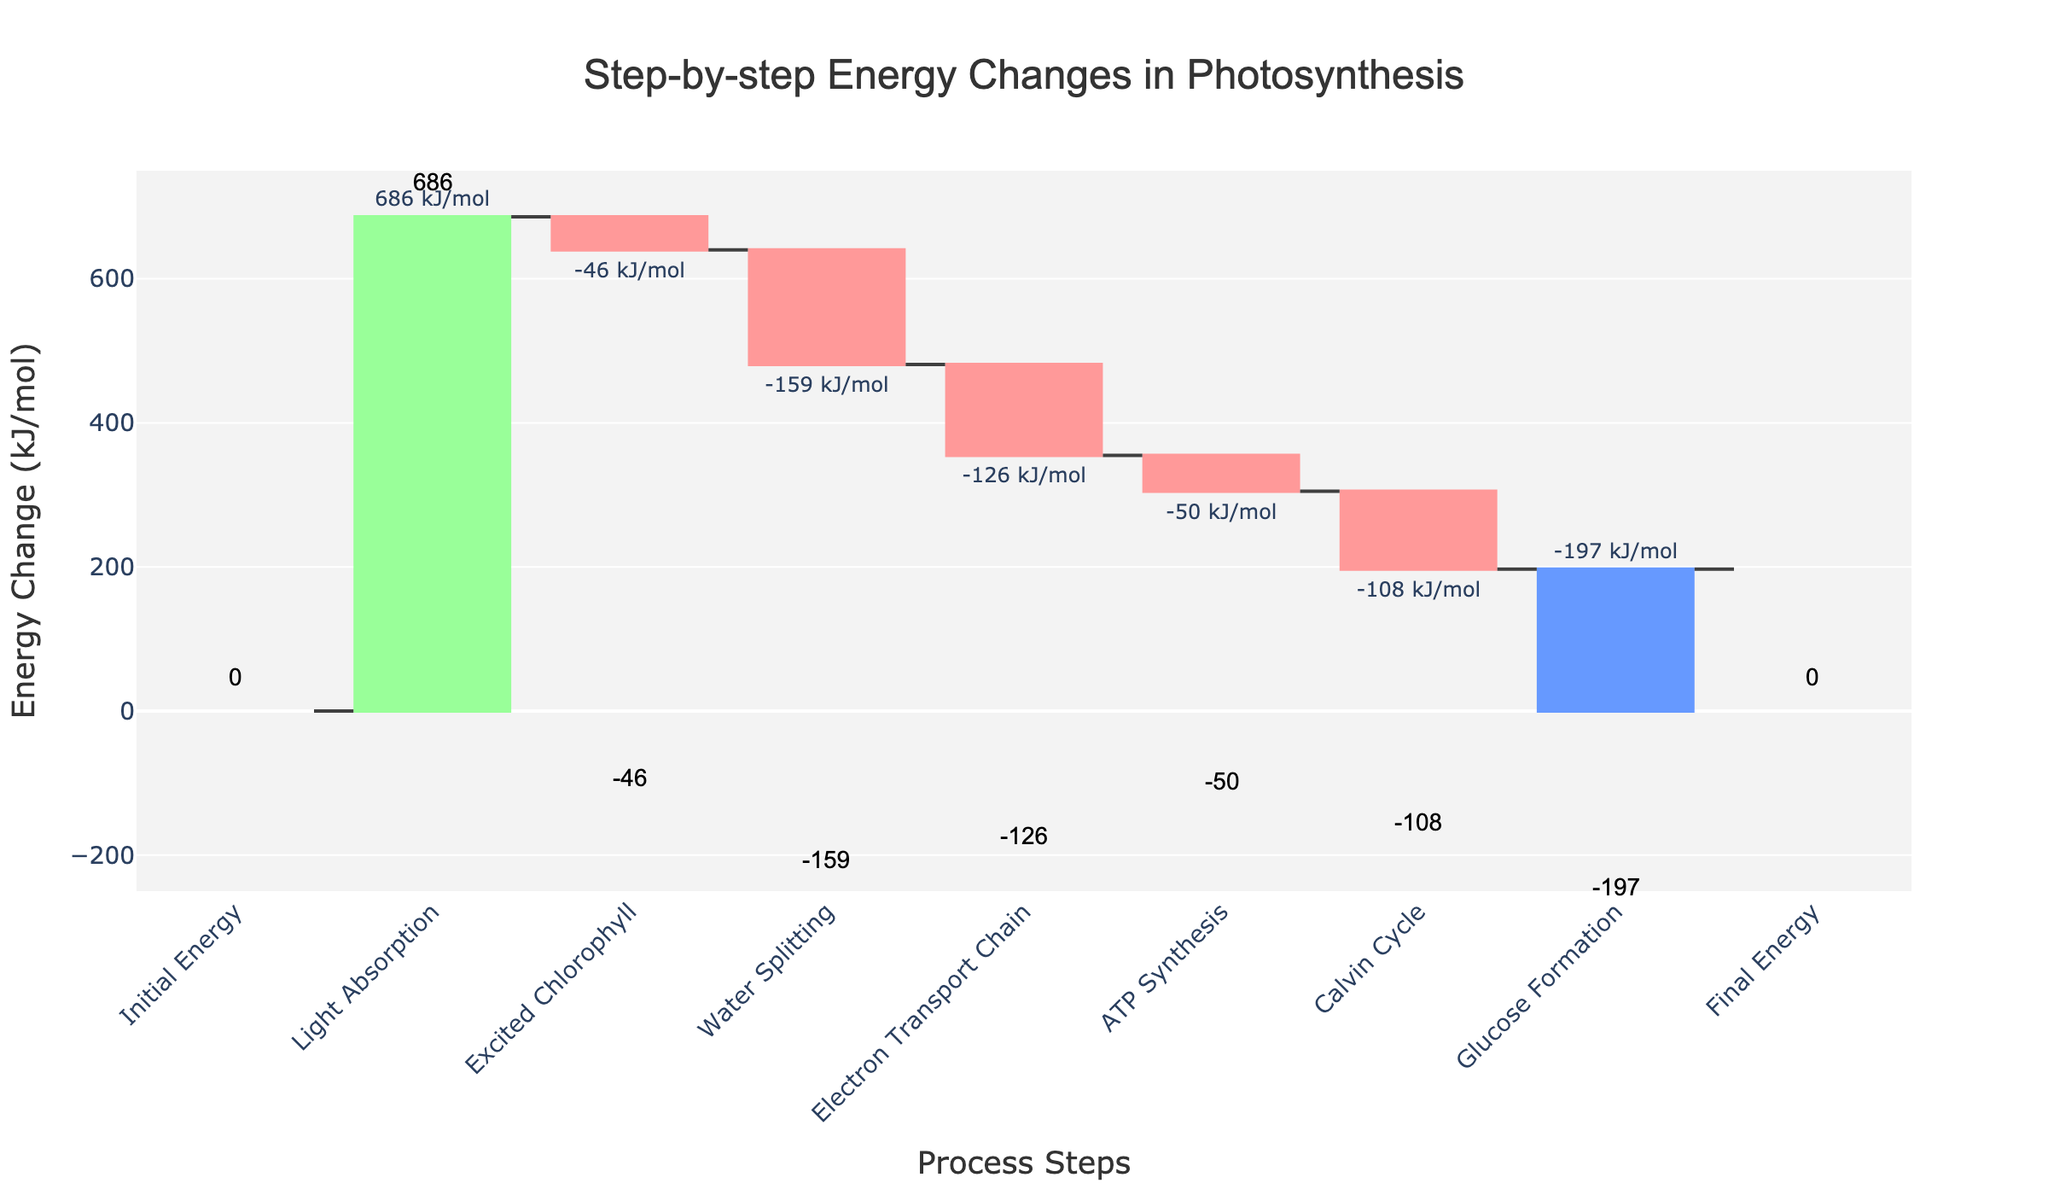What is the title of the chart? The title is displayed at the top of the chart and reads "Step-by-step Energy Changes in Photosynthesis".
Answer: Step-by-step Energy Changes in Photosynthesis What is the energy change during the Light Absorption step? Look at the bar labeled "Light Absorption" and view the text outside the bar indicating the energy change, which is +686 kJ/mol.
Answer: +686 kJ/mol Which steps have a negative energy change? Identify the bars that decrease (marked in red) and note their labels. They are: Excited Chlorophyll (-46 kJ/mol), Water Splitting (-159 kJ/mol), Electron Transport Chain (-126 kJ/mol), ATP Synthesis (-50 kJ/mol), Calvin Cycle (-108 kJ/mol), and Glucose Formation (-197 kJ/mol).
Answer: Excited Chlorophyll, Water Splitting, Electron Transport Chain, ATP Synthesis, Calvin Cycle, Glucose Formation What is the total energy change from the Water Splitting step to the Calvin Cycle step? Sum the energy changes of the steps: Water Splitting (-159) + Electron Transport Chain (-126) + ATP Synthesis (-50) + Calvin Cycle (-108). Total = -159 - 126 - 50 - 108 = -443 kJ/mol.
Answer: -443 kJ/mol Which step has the largest positive energy change and what is its value? By inspecting the bars increasing in height, Light Absorption is the tallest green bar and its energy change is +686 kJ/mol.
Answer: Light Absorption, +686 kJ/mol How does the energy change in the ATP Synthesis step compare to the Calvin Cycle step? Both steps have negative energy changes. ATP Synthesis decreases by -50 kJ/mol, whereas Calvin Cycle decreases by -108 kJ/mol, making the Calvin Cycle step have a greater (more negative) energy change.
Answer: ATP Synthesis is less than Calvin Cycle What’s the net energy change from Initial Energy to Glucose Formation? The net energy change equals the sum of all individual energy changes starting from Initial Energy through Glucose Formation. Initial Energy (0) + Light Absorption (+686) - Excited Chlorophyll (-46) - Water Splitting (-159) - Electron Transport Chain (-126) - ATP Synthesis (-50) - Calvin Cycle (-108) - Glucose Formation (-197) = 0.
Answer: 0 How many steps are in the photosynthesis process represented in the chart? Count the total number of labeled columns from Initial Energy to Final Energy in the x-axis, which count to 9 steps.
Answer: 9 steps Which step marks the return to the Final Energy state, and what is its energy change value? The bar labeled "Final Energy" is where the energy returns to 0 kJ/mol from the Glucose Formation step.
Answer: Final Energy, 0 kJ/mol 